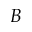<formula> <loc_0><loc_0><loc_500><loc_500>B</formula> 